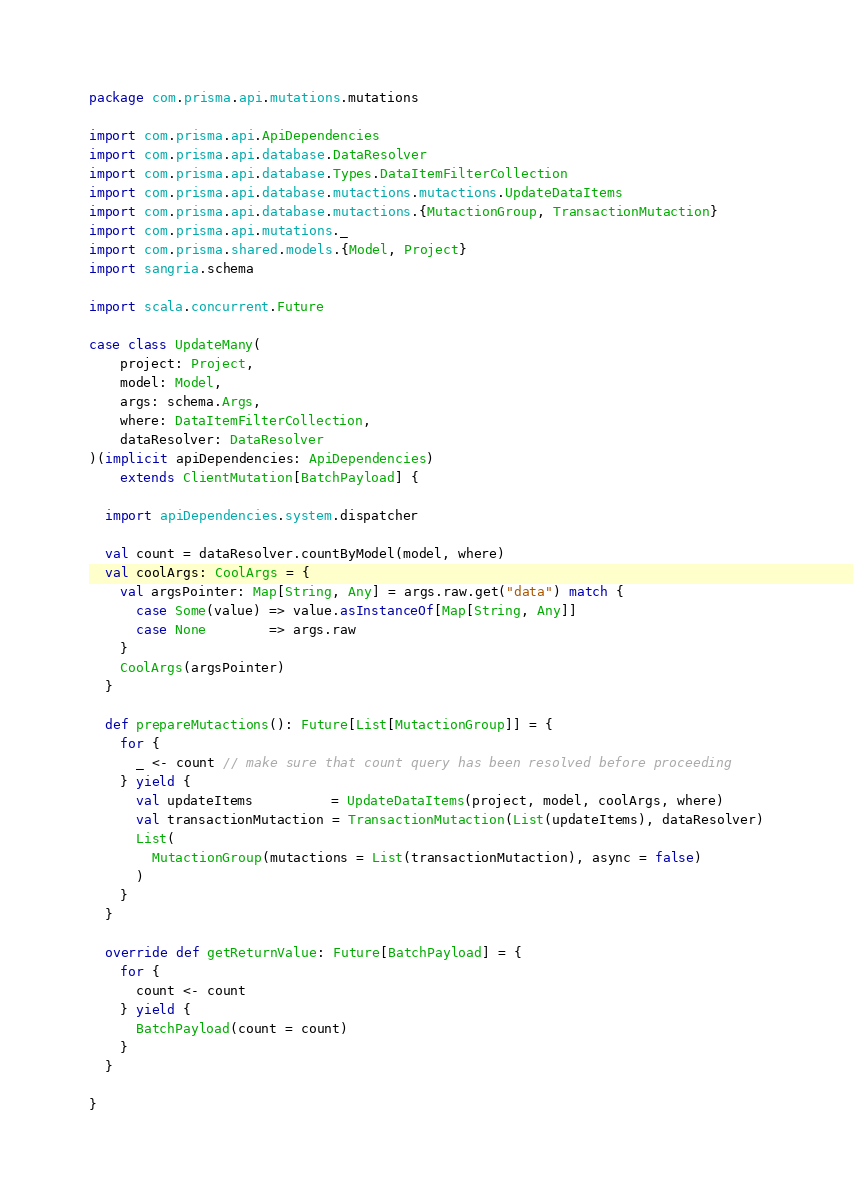Convert code to text. <code><loc_0><loc_0><loc_500><loc_500><_Scala_>package com.prisma.api.mutations.mutations

import com.prisma.api.ApiDependencies
import com.prisma.api.database.DataResolver
import com.prisma.api.database.Types.DataItemFilterCollection
import com.prisma.api.database.mutactions.mutactions.UpdateDataItems
import com.prisma.api.database.mutactions.{MutactionGroup, TransactionMutaction}
import com.prisma.api.mutations._
import com.prisma.shared.models.{Model, Project}
import sangria.schema

import scala.concurrent.Future

case class UpdateMany(
    project: Project,
    model: Model,
    args: schema.Args,
    where: DataItemFilterCollection,
    dataResolver: DataResolver
)(implicit apiDependencies: ApiDependencies)
    extends ClientMutation[BatchPayload] {

  import apiDependencies.system.dispatcher

  val count = dataResolver.countByModel(model, where)
  val coolArgs: CoolArgs = {
    val argsPointer: Map[String, Any] = args.raw.get("data") match {
      case Some(value) => value.asInstanceOf[Map[String, Any]]
      case None        => args.raw
    }
    CoolArgs(argsPointer)
  }

  def prepareMutactions(): Future[List[MutactionGroup]] = {
    for {
      _ <- count // make sure that count query has been resolved before proceeding
    } yield {
      val updateItems          = UpdateDataItems(project, model, coolArgs, where)
      val transactionMutaction = TransactionMutaction(List(updateItems), dataResolver)
      List(
        MutactionGroup(mutactions = List(transactionMutaction), async = false)
      )
    }
  }

  override def getReturnValue: Future[BatchPayload] = {
    for {
      count <- count
    } yield {
      BatchPayload(count = count)
    }
  }

}
</code> 